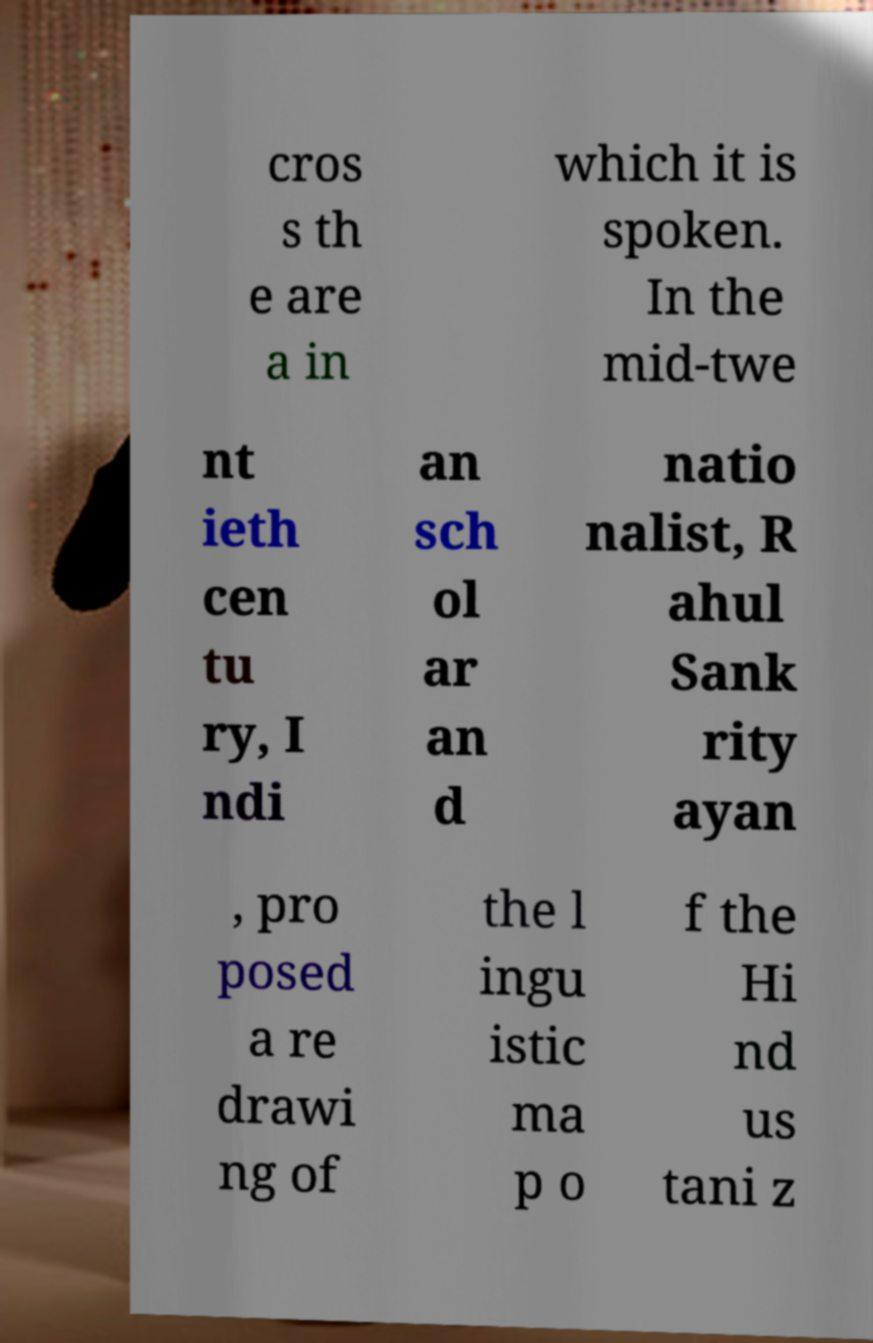Please identify and transcribe the text found in this image. cros s th e are a in which it is spoken. In the mid-twe nt ieth cen tu ry, I ndi an sch ol ar an d natio nalist, R ahul Sank rity ayan , pro posed a re drawi ng of the l ingu istic ma p o f the Hi nd us tani z 